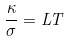Convert formula to latex. <formula><loc_0><loc_0><loc_500><loc_500>\frac { \kappa } { \sigma } = L T</formula> 